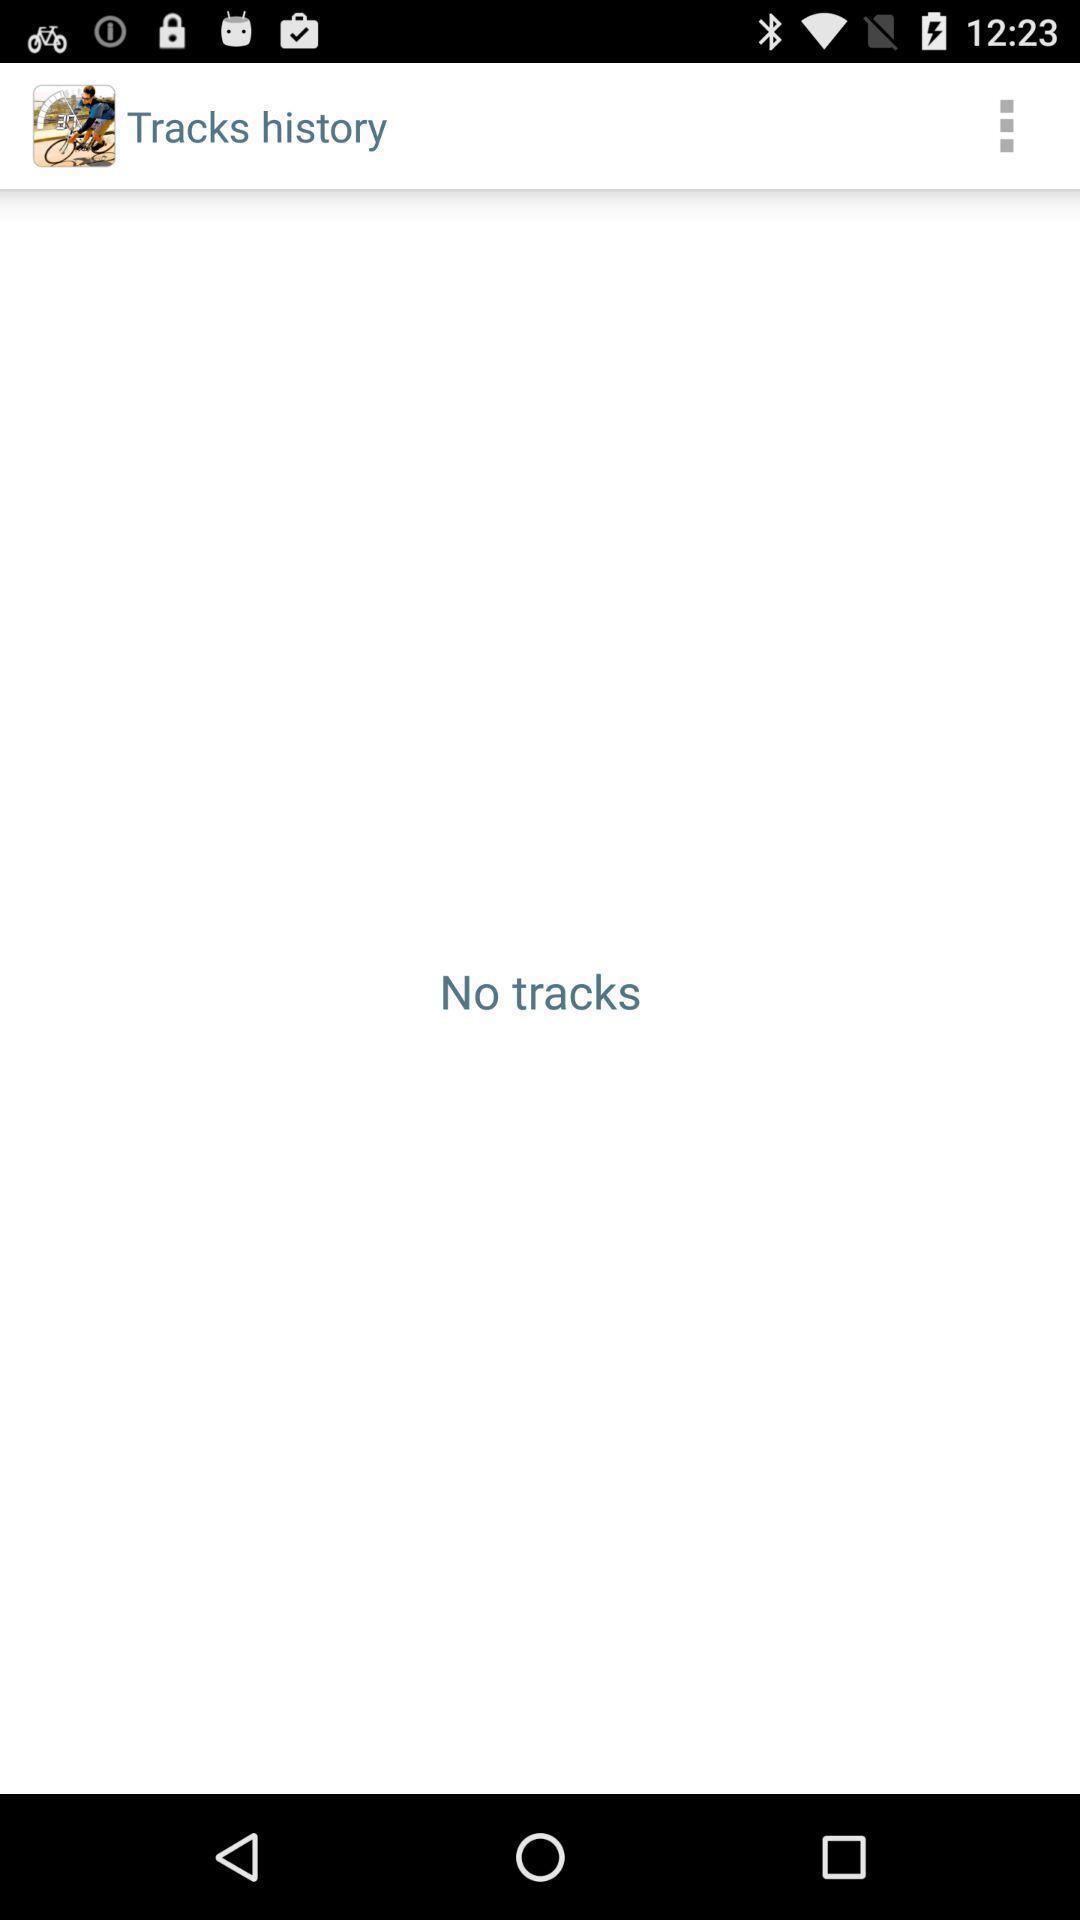Please provide a description for this image. Page showing history. 